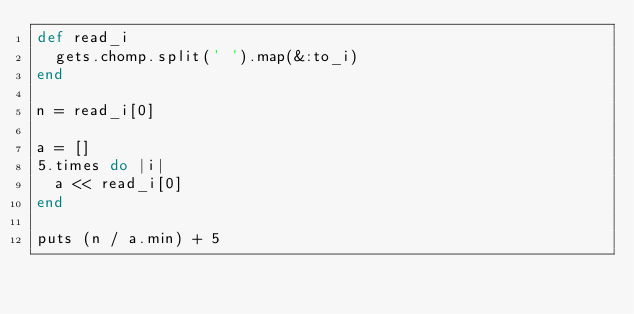<code> <loc_0><loc_0><loc_500><loc_500><_Ruby_>def read_i
  gets.chomp.split(' ').map(&:to_i)
end

n = read_i[0]

a = []
5.times do |i|
  a << read_i[0]
end

puts (n / a.min) + 5</code> 